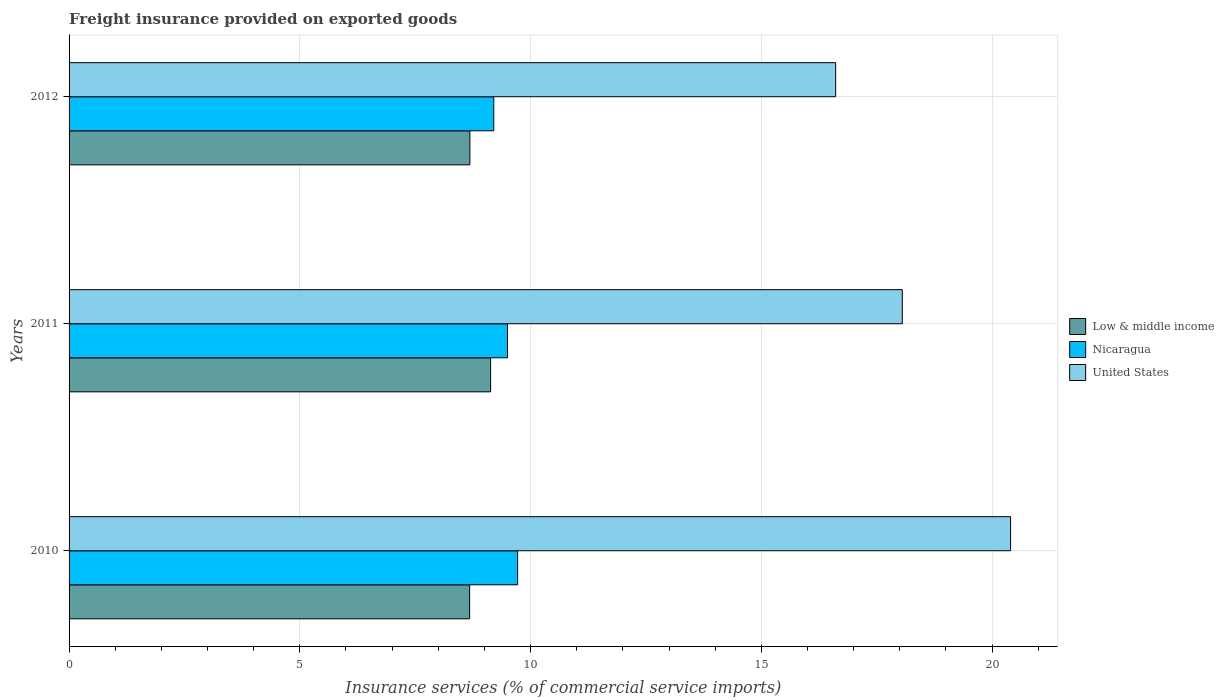Are the number of bars per tick equal to the number of legend labels?
Make the answer very short. Yes. Are the number of bars on each tick of the Y-axis equal?
Provide a succinct answer. Yes. How many bars are there on the 2nd tick from the top?
Offer a very short reply. 3. How many bars are there on the 3rd tick from the bottom?
Keep it short and to the point. 3. What is the freight insurance provided on exported goods in Nicaragua in 2012?
Make the answer very short. 9.2. Across all years, what is the maximum freight insurance provided on exported goods in Low & middle income?
Give a very brief answer. 9.13. Across all years, what is the minimum freight insurance provided on exported goods in Nicaragua?
Your response must be concise. 9.2. In which year was the freight insurance provided on exported goods in United States minimum?
Make the answer very short. 2012. What is the total freight insurance provided on exported goods in Nicaragua in the graph?
Provide a succinct answer. 28.42. What is the difference between the freight insurance provided on exported goods in United States in 2011 and that in 2012?
Your answer should be very brief. 1.44. What is the difference between the freight insurance provided on exported goods in Low & middle income in 2010 and the freight insurance provided on exported goods in Nicaragua in 2012?
Your answer should be very brief. -0.52. What is the average freight insurance provided on exported goods in United States per year?
Offer a very short reply. 18.35. In the year 2010, what is the difference between the freight insurance provided on exported goods in Nicaragua and freight insurance provided on exported goods in Low & middle income?
Provide a short and direct response. 1.04. In how many years, is the freight insurance provided on exported goods in Nicaragua greater than 2 %?
Provide a succinct answer. 3. What is the ratio of the freight insurance provided on exported goods in United States in 2011 to that in 2012?
Give a very brief answer. 1.09. Is the freight insurance provided on exported goods in United States in 2011 less than that in 2012?
Your response must be concise. No. Is the difference between the freight insurance provided on exported goods in Nicaragua in 2010 and 2011 greater than the difference between the freight insurance provided on exported goods in Low & middle income in 2010 and 2011?
Provide a short and direct response. Yes. What is the difference between the highest and the second highest freight insurance provided on exported goods in Low & middle income?
Offer a terse response. 0.45. What is the difference between the highest and the lowest freight insurance provided on exported goods in United States?
Give a very brief answer. 3.79. In how many years, is the freight insurance provided on exported goods in Nicaragua greater than the average freight insurance provided on exported goods in Nicaragua taken over all years?
Give a very brief answer. 2. What does the 3rd bar from the top in 2011 represents?
Your response must be concise. Low & middle income. What does the 2nd bar from the bottom in 2012 represents?
Give a very brief answer. Nicaragua. How many bars are there?
Your answer should be very brief. 9. Are all the bars in the graph horizontal?
Ensure brevity in your answer.  Yes. Does the graph contain any zero values?
Make the answer very short. No. Where does the legend appear in the graph?
Offer a terse response. Center right. How are the legend labels stacked?
Ensure brevity in your answer.  Vertical. What is the title of the graph?
Offer a terse response. Freight insurance provided on exported goods. What is the label or title of the X-axis?
Make the answer very short. Insurance services (% of commercial service imports). What is the label or title of the Y-axis?
Make the answer very short. Years. What is the Insurance services (% of commercial service imports) in Low & middle income in 2010?
Your answer should be compact. 8.68. What is the Insurance services (% of commercial service imports) in Nicaragua in 2010?
Give a very brief answer. 9.72. What is the Insurance services (% of commercial service imports) in United States in 2010?
Make the answer very short. 20.4. What is the Insurance services (% of commercial service imports) of Low & middle income in 2011?
Give a very brief answer. 9.13. What is the Insurance services (% of commercial service imports) in Nicaragua in 2011?
Make the answer very short. 9.5. What is the Insurance services (% of commercial service imports) in United States in 2011?
Your answer should be very brief. 18.05. What is the Insurance services (% of commercial service imports) of Low & middle income in 2012?
Provide a succinct answer. 8.68. What is the Insurance services (% of commercial service imports) in Nicaragua in 2012?
Provide a succinct answer. 9.2. What is the Insurance services (% of commercial service imports) in United States in 2012?
Provide a short and direct response. 16.61. Across all years, what is the maximum Insurance services (% of commercial service imports) of Low & middle income?
Your answer should be compact. 9.13. Across all years, what is the maximum Insurance services (% of commercial service imports) of Nicaragua?
Keep it short and to the point. 9.72. Across all years, what is the maximum Insurance services (% of commercial service imports) in United States?
Offer a very short reply. 20.4. Across all years, what is the minimum Insurance services (% of commercial service imports) in Low & middle income?
Ensure brevity in your answer.  8.68. Across all years, what is the minimum Insurance services (% of commercial service imports) of Nicaragua?
Ensure brevity in your answer.  9.2. Across all years, what is the minimum Insurance services (% of commercial service imports) in United States?
Provide a succinct answer. 16.61. What is the total Insurance services (% of commercial service imports) of Low & middle income in the graph?
Your response must be concise. 26.5. What is the total Insurance services (% of commercial service imports) in Nicaragua in the graph?
Keep it short and to the point. 28.42. What is the total Insurance services (% of commercial service imports) in United States in the graph?
Your response must be concise. 55.06. What is the difference between the Insurance services (% of commercial service imports) of Low & middle income in 2010 and that in 2011?
Provide a succinct answer. -0.45. What is the difference between the Insurance services (% of commercial service imports) in Nicaragua in 2010 and that in 2011?
Keep it short and to the point. 0.22. What is the difference between the Insurance services (% of commercial service imports) of United States in 2010 and that in 2011?
Make the answer very short. 2.35. What is the difference between the Insurance services (% of commercial service imports) of Low & middle income in 2010 and that in 2012?
Your answer should be compact. -0.01. What is the difference between the Insurance services (% of commercial service imports) in Nicaragua in 2010 and that in 2012?
Give a very brief answer. 0.52. What is the difference between the Insurance services (% of commercial service imports) in United States in 2010 and that in 2012?
Your answer should be very brief. 3.79. What is the difference between the Insurance services (% of commercial service imports) in Low & middle income in 2011 and that in 2012?
Keep it short and to the point. 0.45. What is the difference between the Insurance services (% of commercial service imports) in Nicaragua in 2011 and that in 2012?
Keep it short and to the point. 0.3. What is the difference between the Insurance services (% of commercial service imports) in United States in 2011 and that in 2012?
Ensure brevity in your answer.  1.44. What is the difference between the Insurance services (% of commercial service imports) of Low & middle income in 2010 and the Insurance services (% of commercial service imports) of Nicaragua in 2011?
Keep it short and to the point. -0.82. What is the difference between the Insurance services (% of commercial service imports) of Low & middle income in 2010 and the Insurance services (% of commercial service imports) of United States in 2011?
Your answer should be compact. -9.38. What is the difference between the Insurance services (% of commercial service imports) in Nicaragua in 2010 and the Insurance services (% of commercial service imports) in United States in 2011?
Your response must be concise. -8.34. What is the difference between the Insurance services (% of commercial service imports) in Low & middle income in 2010 and the Insurance services (% of commercial service imports) in Nicaragua in 2012?
Offer a terse response. -0.52. What is the difference between the Insurance services (% of commercial service imports) of Low & middle income in 2010 and the Insurance services (% of commercial service imports) of United States in 2012?
Offer a very short reply. -7.93. What is the difference between the Insurance services (% of commercial service imports) of Nicaragua in 2010 and the Insurance services (% of commercial service imports) of United States in 2012?
Give a very brief answer. -6.89. What is the difference between the Insurance services (% of commercial service imports) in Low & middle income in 2011 and the Insurance services (% of commercial service imports) in Nicaragua in 2012?
Ensure brevity in your answer.  -0.07. What is the difference between the Insurance services (% of commercial service imports) in Low & middle income in 2011 and the Insurance services (% of commercial service imports) in United States in 2012?
Your answer should be very brief. -7.48. What is the difference between the Insurance services (% of commercial service imports) in Nicaragua in 2011 and the Insurance services (% of commercial service imports) in United States in 2012?
Ensure brevity in your answer.  -7.11. What is the average Insurance services (% of commercial service imports) in Low & middle income per year?
Provide a short and direct response. 8.83. What is the average Insurance services (% of commercial service imports) in Nicaragua per year?
Keep it short and to the point. 9.47. What is the average Insurance services (% of commercial service imports) in United States per year?
Your answer should be compact. 18.35. In the year 2010, what is the difference between the Insurance services (% of commercial service imports) in Low & middle income and Insurance services (% of commercial service imports) in Nicaragua?
Provide a short and direct response. -1.04. In the year 2010, what is the difference between the Insurance services (% of commercial service imports) in Low & middle income and Insurance services (% of commercial service imports) in United States?
Keep it short and to the point. -11.72. In the year 2010, what is the difference between the Insurance services (% of commercial service imports) in Nicaragua and Insurance services (% of commercial service imports) in United States?
Provide a short and direct response. -10.68. In the year 2011, what is the difference between the Insurance services (% of commercial service imports) in Low & middle income and Insurance services (% of commercial service imports) in Nicaragua?
Ensure brevity in your answer.  -0.37. In the year 2011, what is the difference between the Insurance services (% of commercial service imports) of Low & middle income and Insurance services (% of commercial service imports) of United States?
Make the answer very short. -8.92. In the year 2011, what is the difference between the Insurance services (% of commercial service imports) of Nicaragua and Insurance services (% of commercial service imports) of United States?
Your answer should be very brief. -8.55. In the year 2012, what is the difference between the Insurance services (% of commercial service imports) in Low & middle income and Insurance services (% of commercial service imports) in Nicaragua?
Your answer should be very brief. -0.52. In the year 2012, what is the difference between the Insurance services (% of commercial service imports) in Low & middle income and Insurance services (% of commercial service imports) in United States?
Make the answer very short. -7.93. In the year 2012, what is the difference between the Insurance services (% of commercial service imports) of Nicaragua and Insurance services (% of commercial service imports) of United States?
Offer a terse response. -7.41. What is the ratio of the Insurance services (% of commercial service imports) in Low & middle income in 2010 to that in 2011?
Keep it short and to the point. 0.95. What is the ratio of the Insurance services (% of commercial service imports) in Nicaragua in 2010 to that in 2011?
Your answer should be compact. 1.02. What is the ratio of the Insurance services (% of commercial service imports) of United States in 2010 to that in 2011?
Your answer should be very brief. 1.13. What is the ratio of the Insurance services (% of commercial service imports) of Nicaragua in 2010 to that in 2012?
Give a very brief answer. 1.06. What is the ratio of the Insurance services (% of commercial service imports) in United States in 2010 to that in 2012?
Offer a very short reply. 1.23. What is the ratio of the Insurance services (% of commercial service imports) of Low & middle income in 2011 to that in 2012?
Keep it short and to the point. 1.05. What is the ratio of the Insurance services (% of commercial service imports) of Nicaragua in 2011 to that in 2012?
Give a very brief answer. 1.03. What is the ratio of the Insurance services (% of commercial service imports) of United States in 2011 to that in 2012?
Make the answer very short. 1.09. What is the difference between the highest and the second highest Insurance services (% of commercial service imports) in Low & middle income?
Provide a succinct answer. 0.45. What is the difference between the highest and the second highest Insurance services (% of commercial service imports) of Nicaragua?
Ensure brevity in your answer.  0.22. What is the difference between the highest and the second highest Insurance services (% of commercial service imports) in United States?
Provide a succinct answer. 2.35. What is the difference between the highest and the lowest Insurance services (% of commercial service imports) of Low & middle income?
Ensure brevity in your answer.  0.45. What is the difference between the highest and the lowest Insurance services (% of commercial service imports) in Nicaragua?
Offer a terse response. 0.52. What is the difference between the highest and the lowest Insurance services (% of commercial service imports) of United States?
Your answer should be very brief. 3.79. 